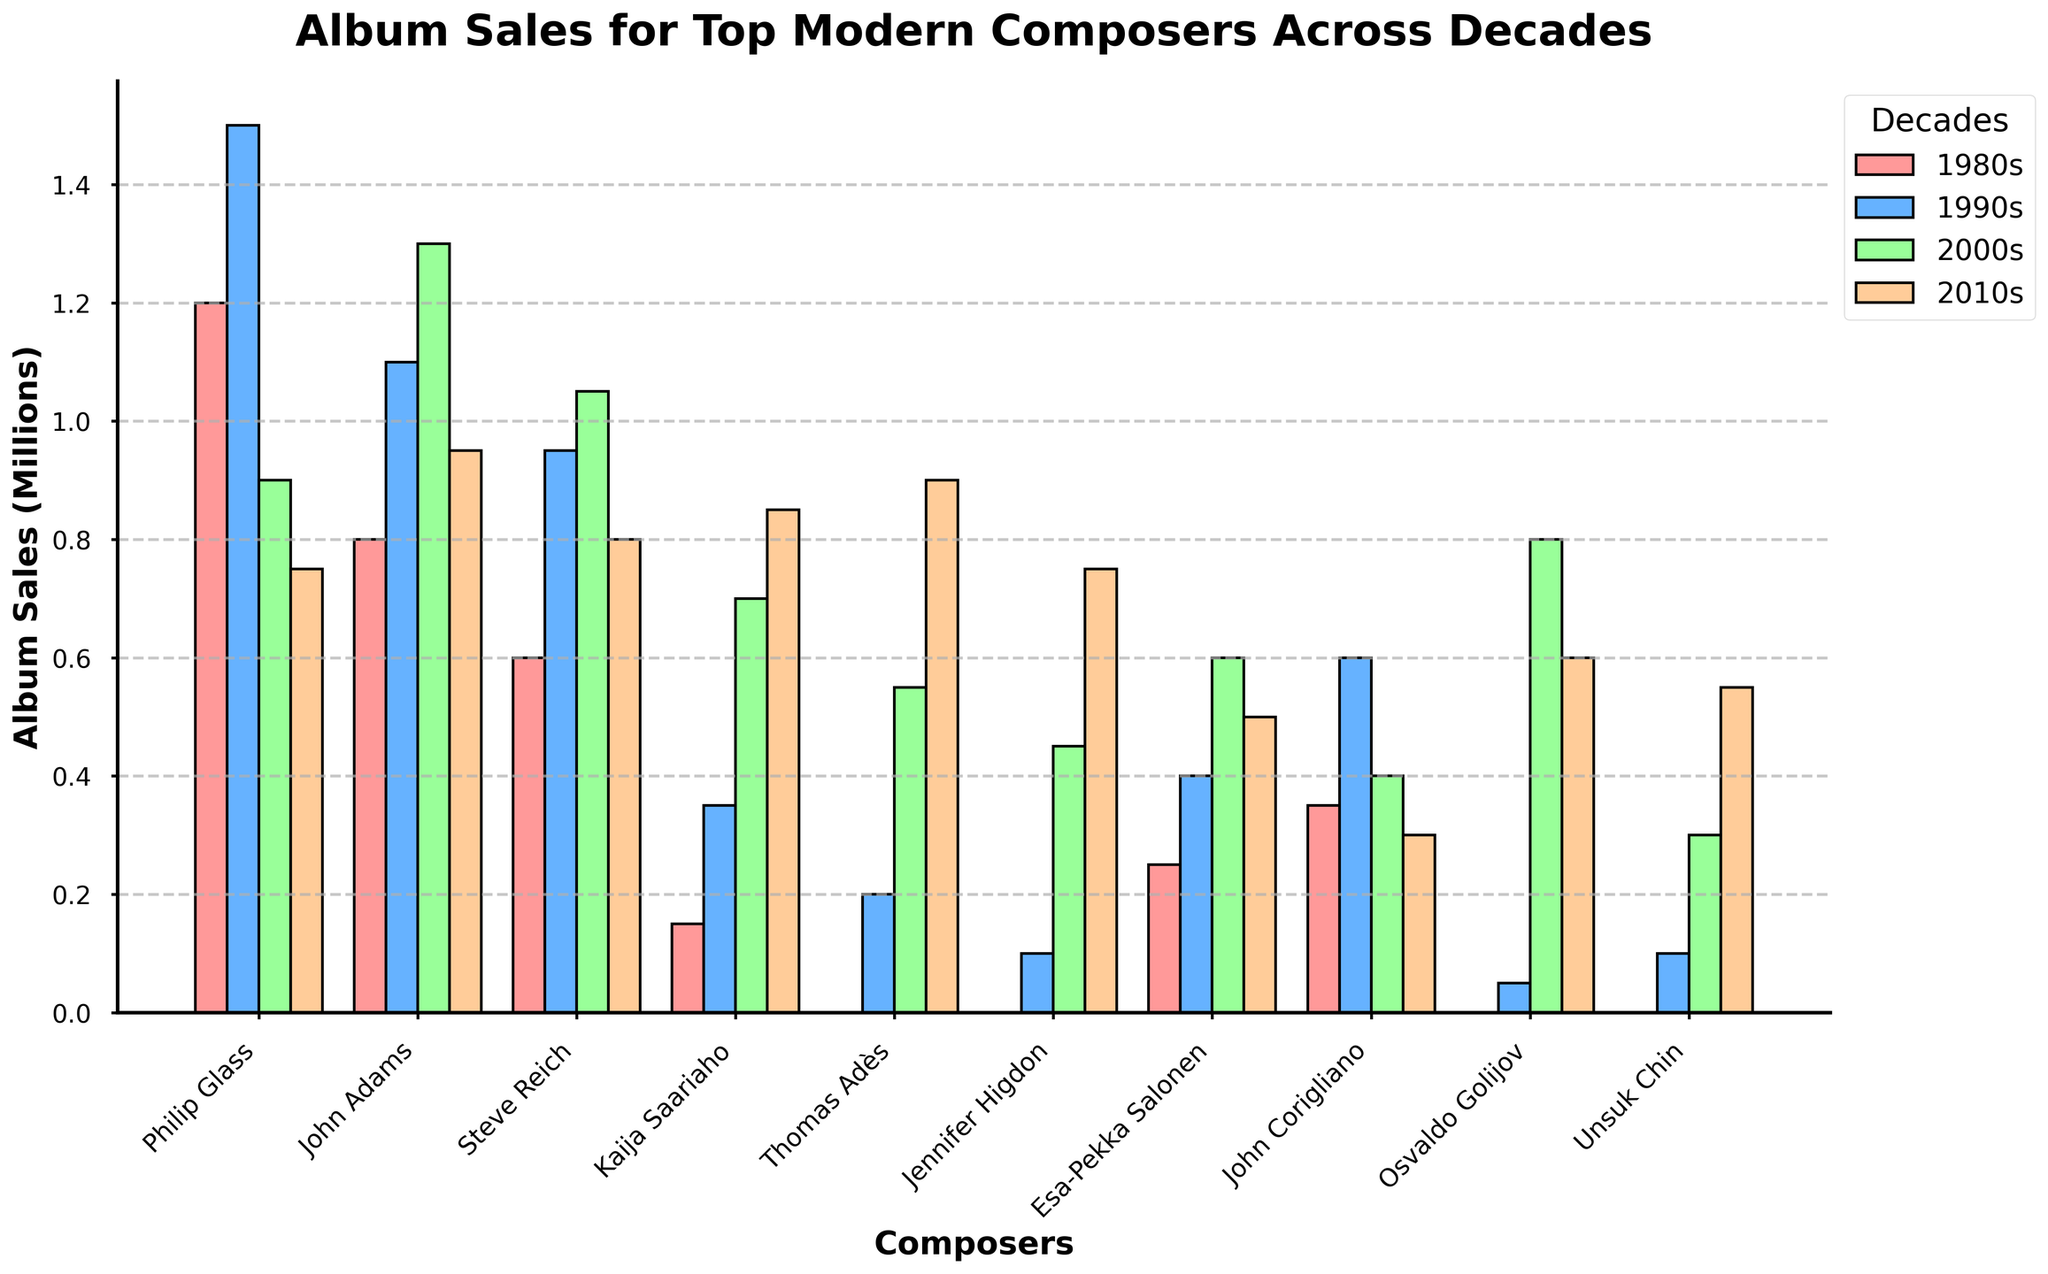How much did Philip Glass's album sales decline from the 1990s to the 2010s? To find the decline in Philip Glass's album sales, subtract the sales in the 2010s from the sales in the 1990s: 1,500,000 (1990s) - 750,000 (2010s) = 750,000.
Answer: 750,000 Which composer had the highest album sales in the 2000s? By scanning the height of the bars for the 2000s decade, John Adams's bar is the tallest, indicating he had the highest sales.
Answer: John Adams Considering the 1980s, which composer had the least album sales? By looking at the bars for the 1980s, Kaija Saariaho's bar is the shortest amongst those who have data for that decade.
Answer: Kaija Saariaho What is the total combined album sales for Esa-Pekka Salonen across all decades? Sum the album sales for all decades: 250,000 (1980s) + 400,000 (1990s) + 600,000 (2000s) + 500,000 (2010s) = 1,750,000.
Answer: 1,750,000 Which decade had the most digital album sales for Steve Reich? Check the bar heights for Steve Reich across the decades, the 2000s have the highest bar.
Answer: 2000s In which decade did Kaija Saariaho see the greatest increase in album sales compared to the previous decade? Calculate the differences between subsequent decades: 350,000 - 150,000 (1990s from 1980s) = 200,000; 700,000 - 350,000 (2000s from 1990s) = 350,000; and 850,000 - 700,000 (2010s from 2000s) = 150,000. The largest increase is seen from the 1990s to the 2000s.
Answer: 2000s Which composer showed an increase in album sales in every decade? By checking the bars' height for each composer over time, we see that Kaija Saariaho's album sales increased in every decade.
Answer: Kaija Saariaho What is the most common color used in the bar chart to represent the data? The bar colors alternate for each decade but are mostly red, blue, green, and orange. By frequency, each color appears the same number of times across the chart.
Answer: Red, blue, green, orange Among John Corigliano and Philip Glass, who experienced a larger decline in album sales from the 2000s to the 2010s? Calculate the declines: Philip Glass's decline = 900,000 (2000s) - 750,000 (2010s) = 150,000; John Corigliano's decline = 400,000 (2000s) - 300,000 (2010s) = 100,000. So, Philip Glass had a larger decline.
Answer: Philip Glass 